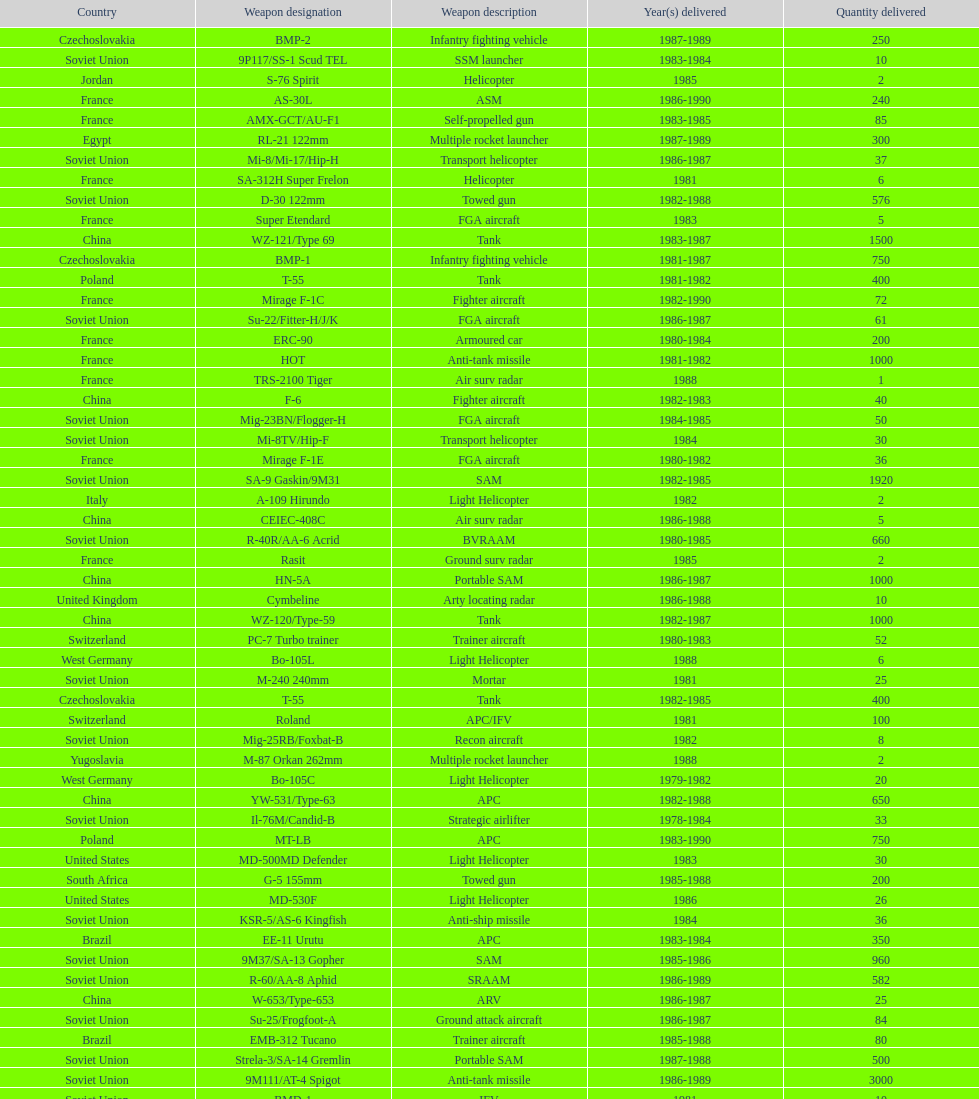Which country had the largest number of towed guns delivered? Soviet Union. 